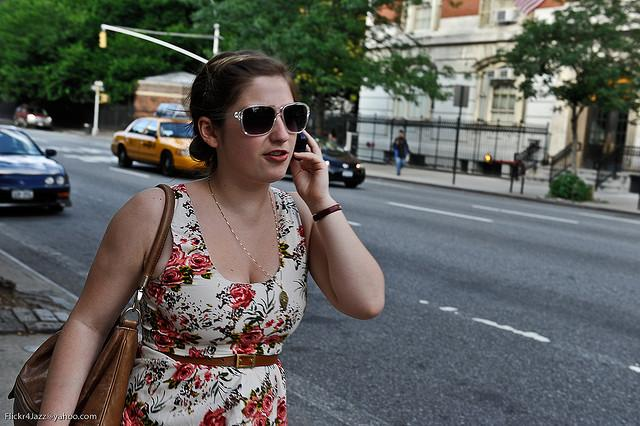What is the woman wearing sunglasses doing? talking 